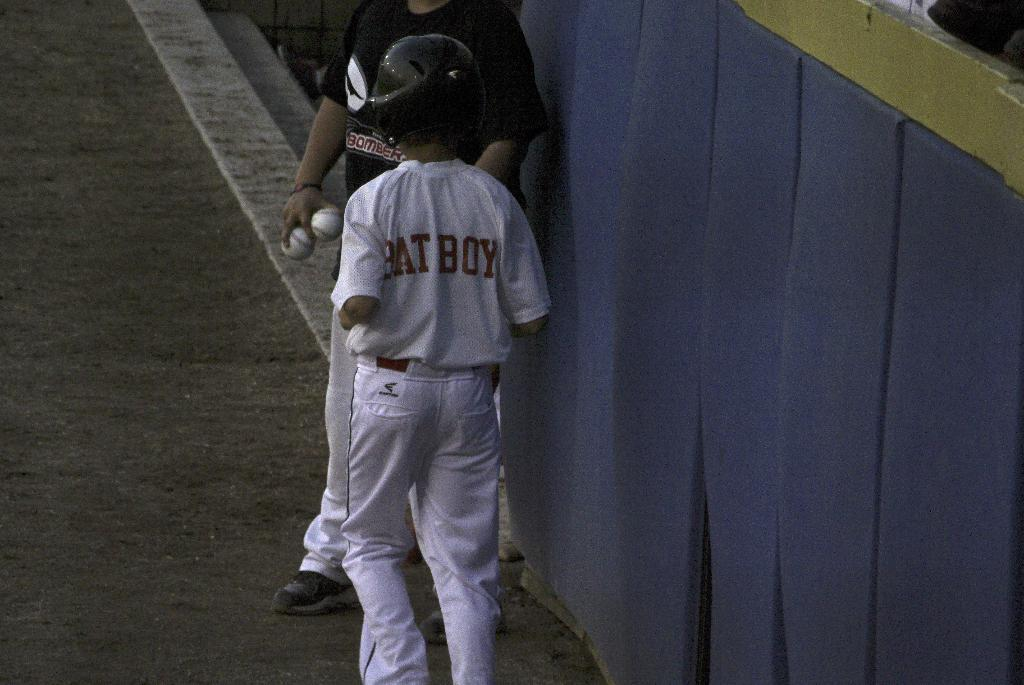<image>
Write a terse but informative summary of the picture. a person that has bat boy written on their jersey 